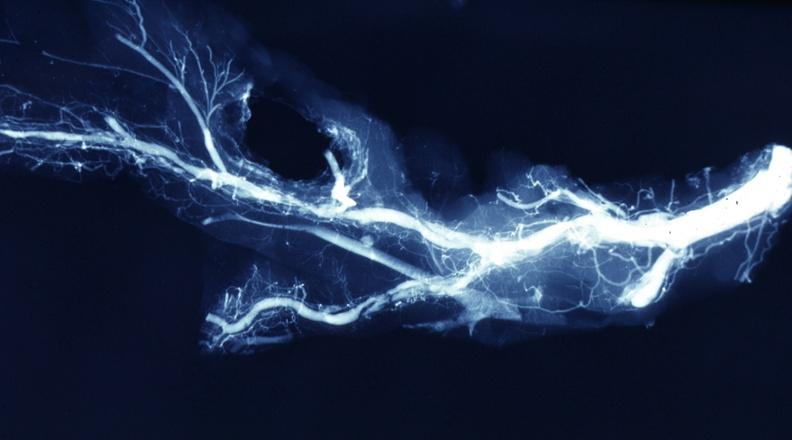s cardiovascular present?
Answer the question using a single word or phrase. Yes 